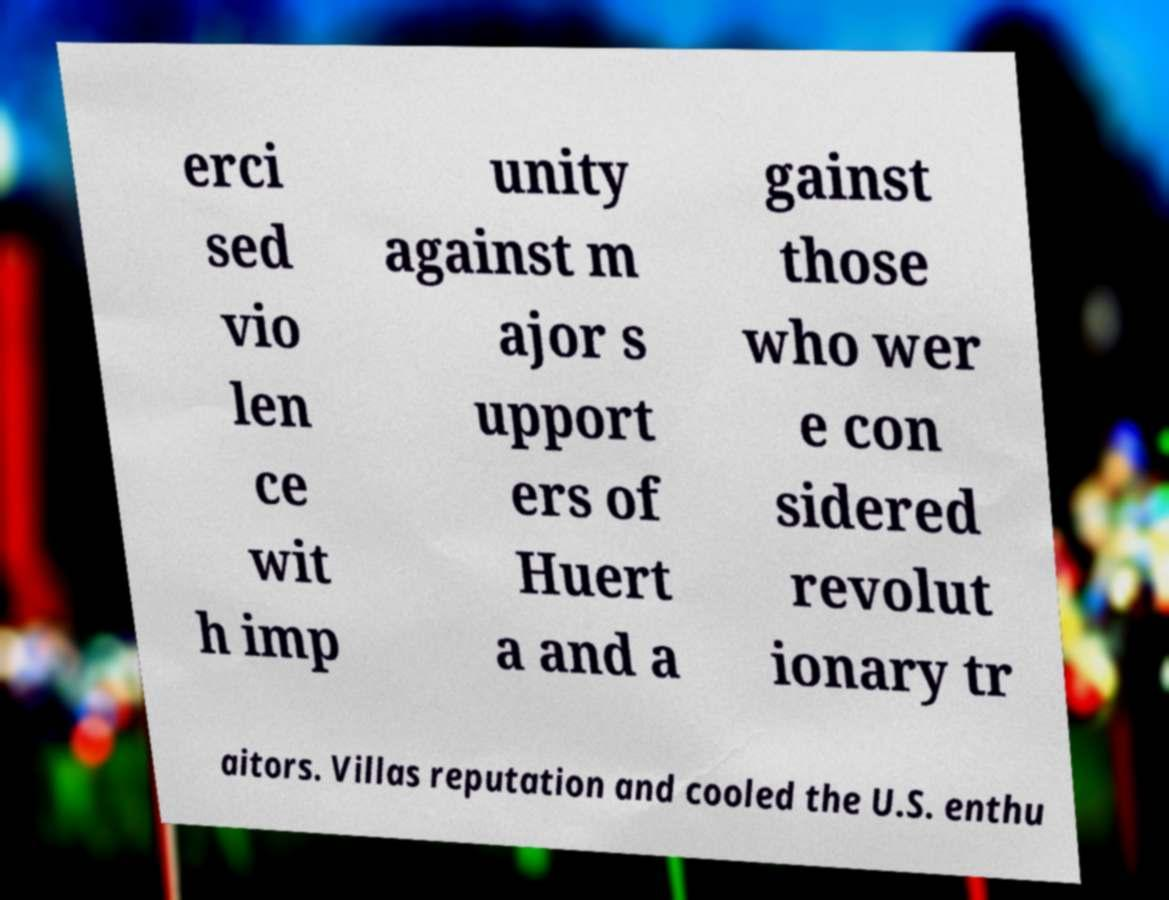Please read and relay the text visible in this image. What does it say? erci sed vio len ce wit h imp unity against m ajor s upport ers of Huert a and a gainst those who wer e con sidered revolut ionary tr aitors. Villas reputation and cooled the U.S. enthu 